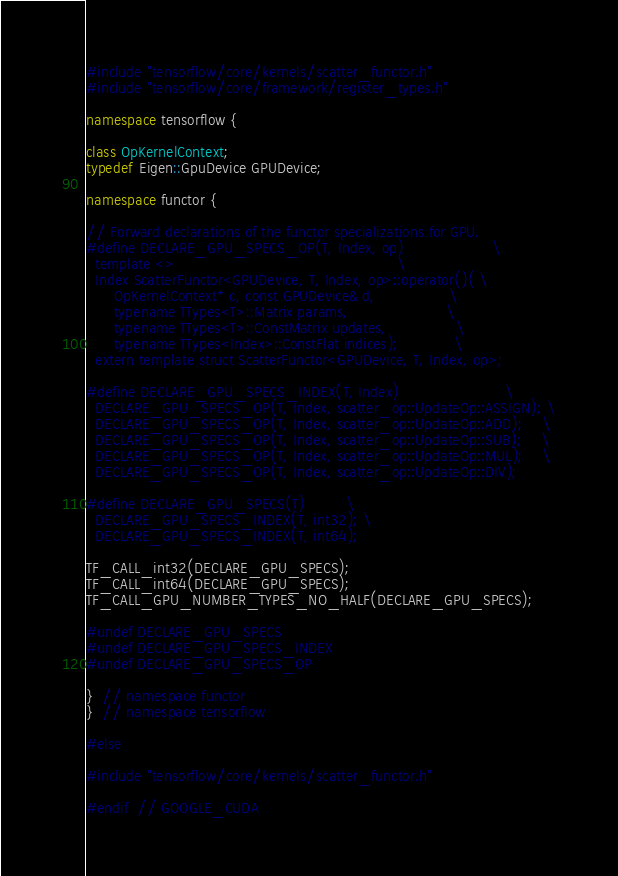Convert code to text. <code><loc_0><loc_0><loc_500><loc_500><_C++_>
#include "tensorflow/core/kernels/scatter_functor.h"
#include "tensorflow/core/framework/register_types.h"

namespace tensorflow {

class OpKernelContext;
typedef Eigen::GpuDevice GPUDevice;

namespace functor {

// Forward declarations of the functor specializations for GPU.
#define DECLARE_GPU_SPECS_OP(T, Index, op)                   \
  template <>                                                \
  Index ScatterFunctor<GPUDevice, T, Index, op>::operator()( \
      OpKernelContext* c, const GPUDevice& d,                \
      typename TTypes<T>::Matrix params,                     \
      typename TTypes<T>::ConstMatrix updates,               \
      typename TTypes<Index>::ConstFlat indices);            \
  extern template struct ScatterFunctor<GPUDevice, T, Index, op>;

#define DECLARE_GPU_SPECS_INDEX(T, Index)                       \
  DECLARE_GPU_SPECS_OP(T, Index, scatter_op::UpdateOp::ASSIGN); \
  DECLARE_GPU_SPECS_OP(T, Index, scatter_op::UpdateOp::ADD);    \
  DECLARE_GPU_SPECS_OP(T, Index, scatter_op::UpdateOp::SUB);    \
  DECLARE_GPU_SPECS_OP(T, Index, scatter_op::UpdateOp::MUL);    \
  DECLARE_GPU_SPECS_OP(T, Index, scatter_op::UpdateOp::DIV);

#define DECLARE_GPU_SPECS(T)         \
  DECLARE_GPU_SPECS_INDEX(T, int32); \
  DECLARE_GPU_SPECS_INDEX(T, int64);

TF_CALL_int32(DECLARE_GPU_SPECS);
TF_CALL_int64(DECLARE_GPU_SPECS);
TF_CALL_GPU_NUMBER_TYPES_NO_HALF(DECLARE_GPU_SPECS);

#undef DECLARE_GPU_SPECS
#undef DECLARE_GPU_SPECS_INDEX
#undef DECLARE_GPU_SPECS_OP

}  // namespace functor
}  // namespace tensorflow

#else

#include "tensorflow/core/kernels/scatter_functor.h"

#endif  // GOOGLE_CUDA
</code> 